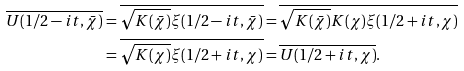Convert formula to latex. <formula><loc_0><loc_0><loc_500><loc_500>\overline { U ( 1 / 2 - i t , \bar { \chi } ) } & = \overline { \sqrt { K ( \bar { \chi } ) } \xi ( 1 / 2 - i t , \bar { \chi } ) } = \overline { \sqrt { K ( \bar { \chi } ) } K ( \chi ) \xi ( 1 / 2 + i t , \chi ) } \\ & = \overline { \sqrt { K ( \chi ) } \xi ( 1 / 2 + i t , \chi ) } = \overline { U ( 1 / 2 + i t , \chi ) } .</formula> 